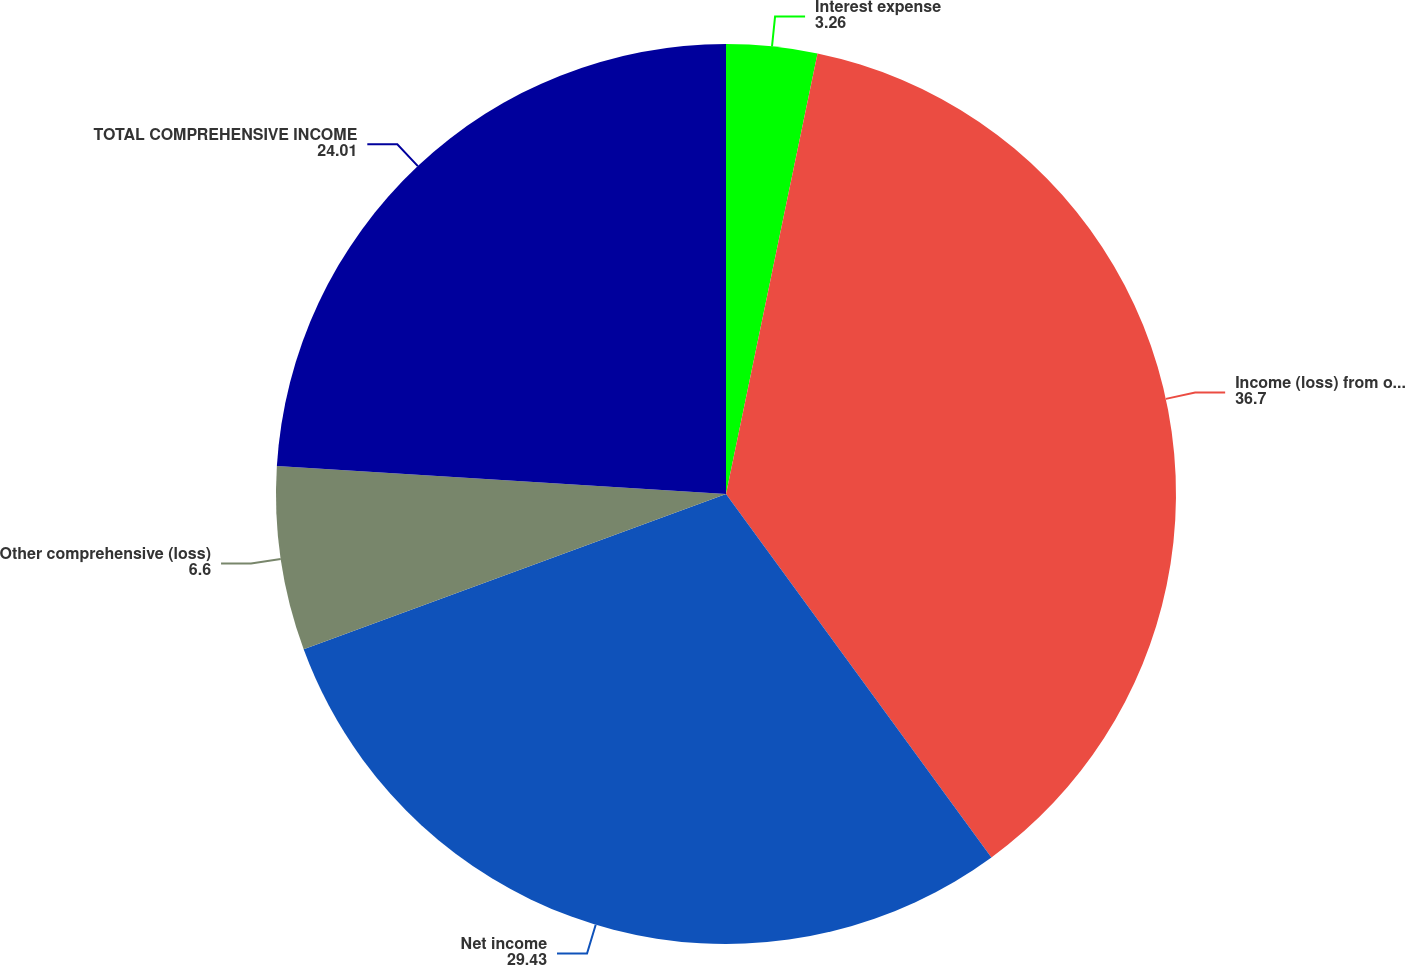<chart> <loc_0><loc_0><loc_500><loc_500><pie_chart><fcel>Interest expense<fcel>Income (loss) from operations<fcel>Net income<fcel>Other comprehensive (loss)<fcel>TOTAL COMPREHENSIVE INCOME<nl><fcel>3.26%<fcel>36.7%<fcel>29.43%<fcel>6.6%<fcel>24.01%<nl></chart> 